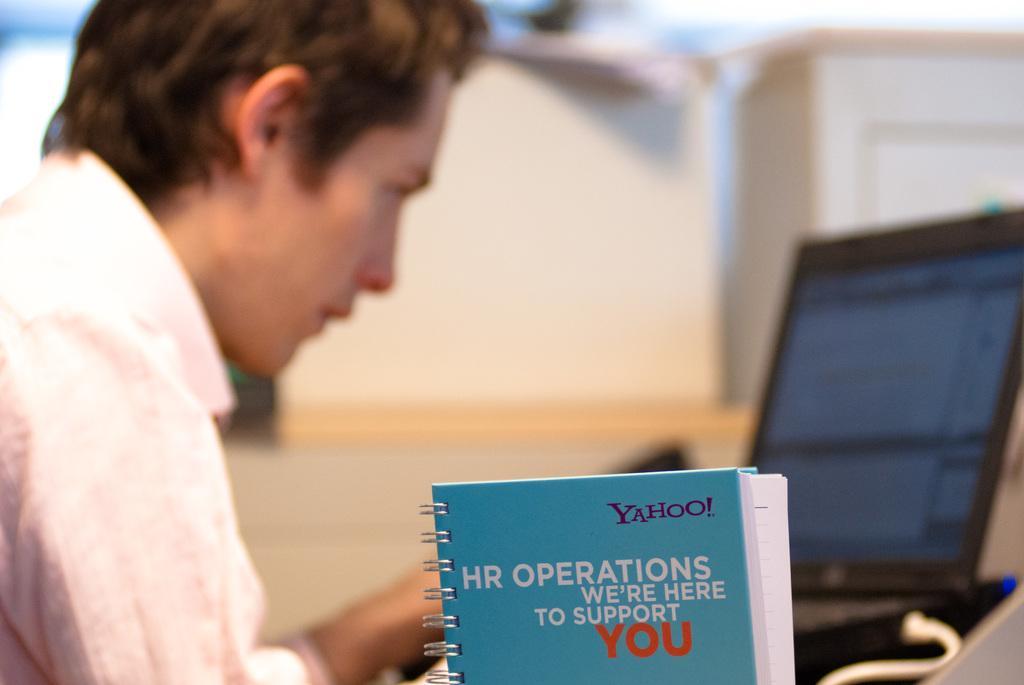Can you describe this image briefly? On the left side of the image we can see a man is sitting and wearing shirt. On the right side of the image we can see a laptop with wire. At the bottom of the image we can see a book. In the center of the image we can see a table. On the table we can see the boxes and papers. At the top, the image is blur. 